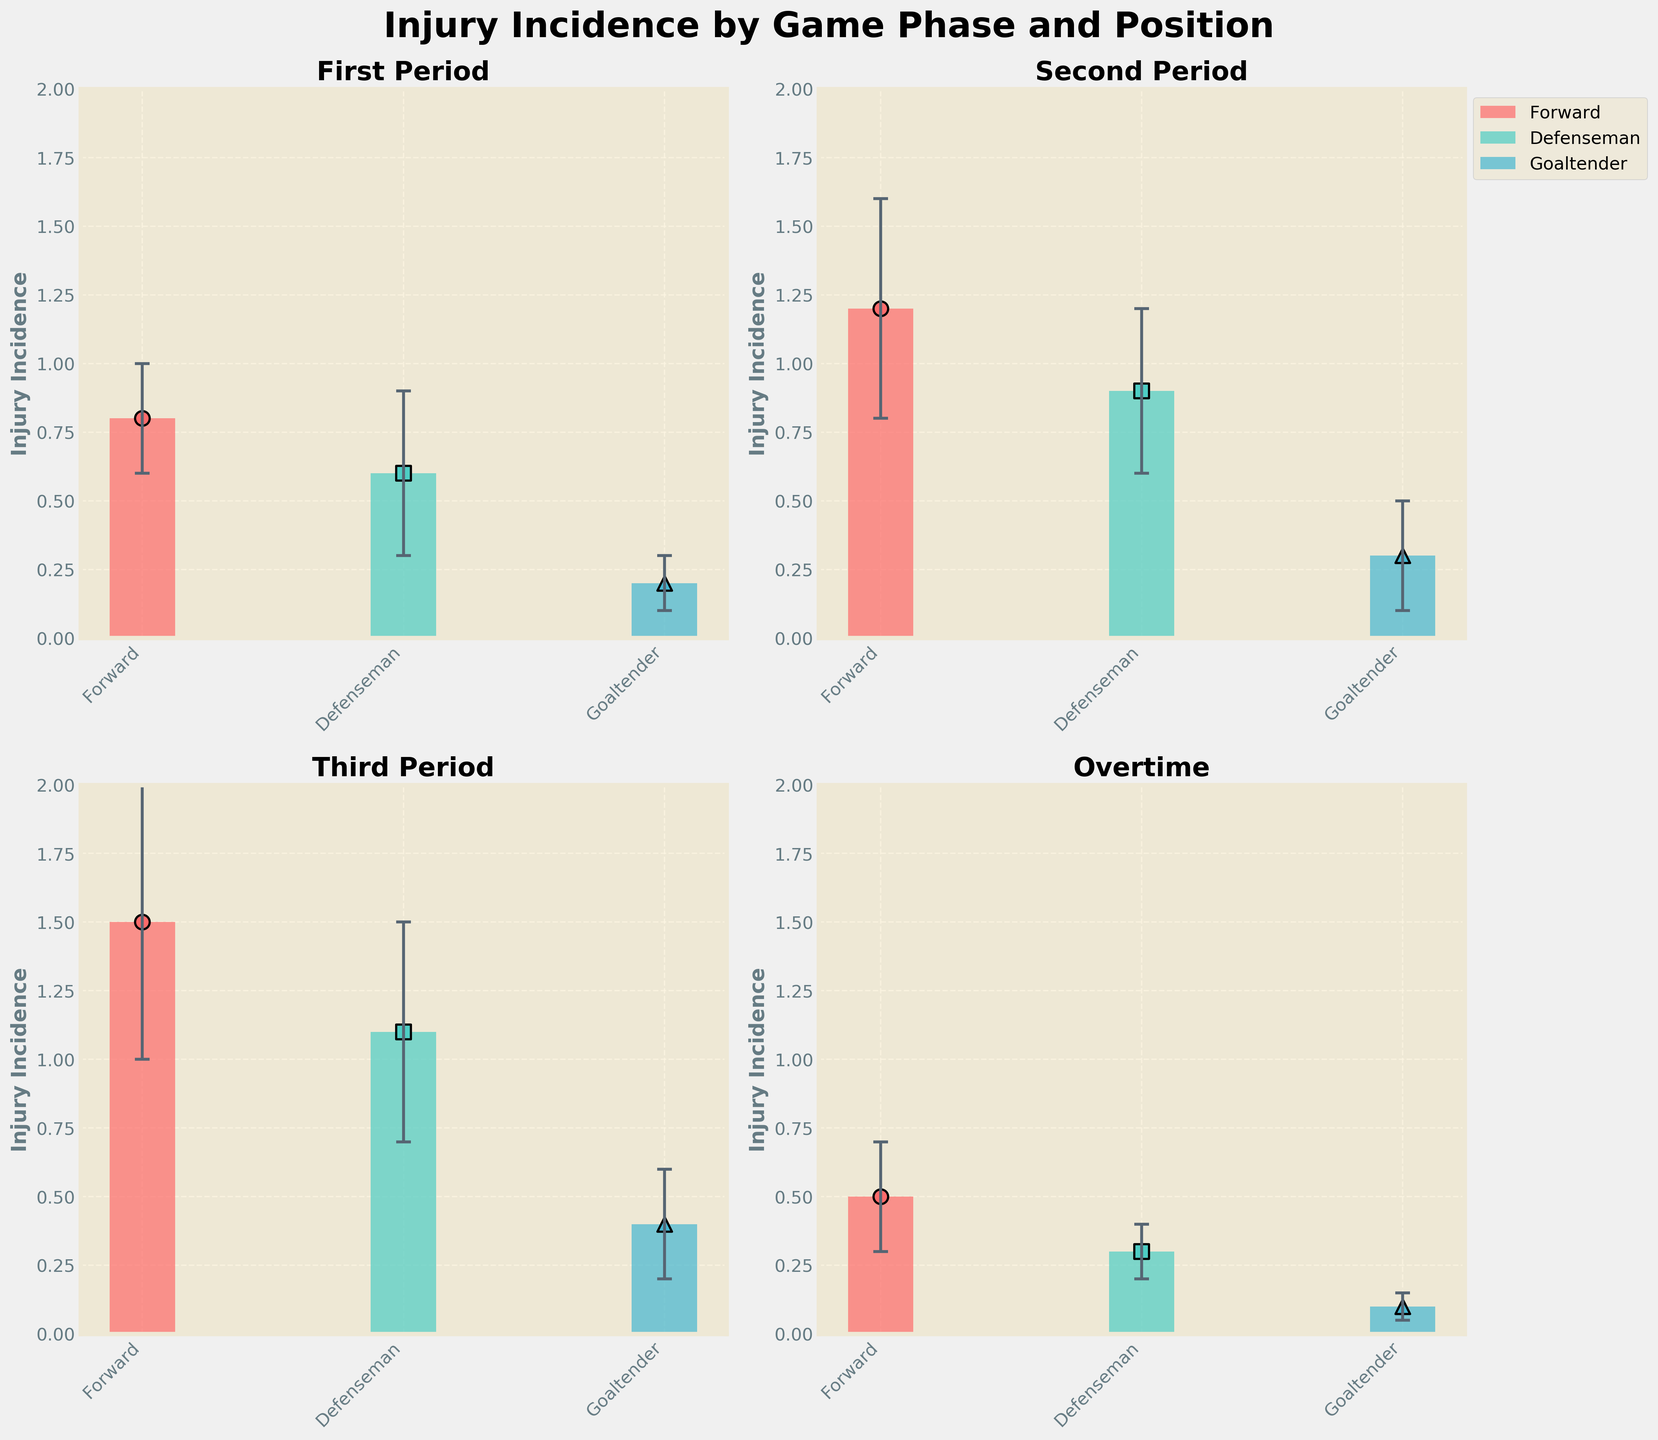What does the title of the plot tell us? The title "Injury Incidence by Game Phase and Position" indicates that the plot presents data on the frequency of injuries, categorized by different game phases (First Period, Second Period, Third Period, Overtime) and player positions (Forward, Defenseman, Goaltender).
Answer: Injury Incidence by Game Phase and Position What game phase shows the highest mean injury incidence for forwards? From the subplots, we can see that "Third Period" has the highest mean injury incidence for forwards, with an incidence rate of 1.5.
Answer: Third Period Which position has the lowest mean injury incidence during the Overtime phase, and what is the value? The subplot for "Overtime" shows that the Goaltender position has the lowest mean injury incidence, with an incidence rate of 0.1.
Answer: Goaltender, 0.1 What is the difference in mean injury incidence between Defensemen in the First Period and Third Period? The bar for Defensemen in the First Period shows a mean injury incidence of 0.6, and in the Third Period, it is 1.1. The difference is \(1.1 - 0.6 = 0.5\).
Answer: 0.5 Which game phase shows the overall lowest variability in injury incidence across all positions? The figure shows error bars to represent standard deviation. The smallest error bars appear in the "Overtime" phase, indicating the lowest variability.
Answer: Overtime How does the mean injury incidence for Goaltenders change from the Second Period to the Third Period? The subplot for the Second Period shows a mean injury incidence of 0.3 for Goaltenders, while the Third Period shows a mean injury incidence of 0.4. The change is \(0.4 - 0.3 = 0.1\).
Answer: Increases by 0.1 Compare the injury incidence between Forwards and Defensemen in the Second Period. Which position has a higher incidence, and by how much? In the Second Period, Forwards have a mean injury incidence of 1.2, while Defensemen have 0.9. The difference is \(1.2 - 0.9 = 0.3\), so Forwards have a higher incidence by 0.3.
Answer: Forwards, 0.3 What trend can be observed in the mean injury incidence of Forwards across the game phases? The mean injury incidence for Forwards increases from the First Period (0.8), peaks in the Third Period (1.5), and then decreases in Overtime (0.5).
Answer: Increases then decreases In which game phase is the mean injury incidence for Goaltenders significantly different from the Forward and Defenseman positions? Explain. During the First Period, the mean injury incidence for Goaltenders (0.2) is much lower compared to Forwards (0.8) and Defensemen (0.6). Therefore, the First Period shows a significant difference.
Answer: First Period 